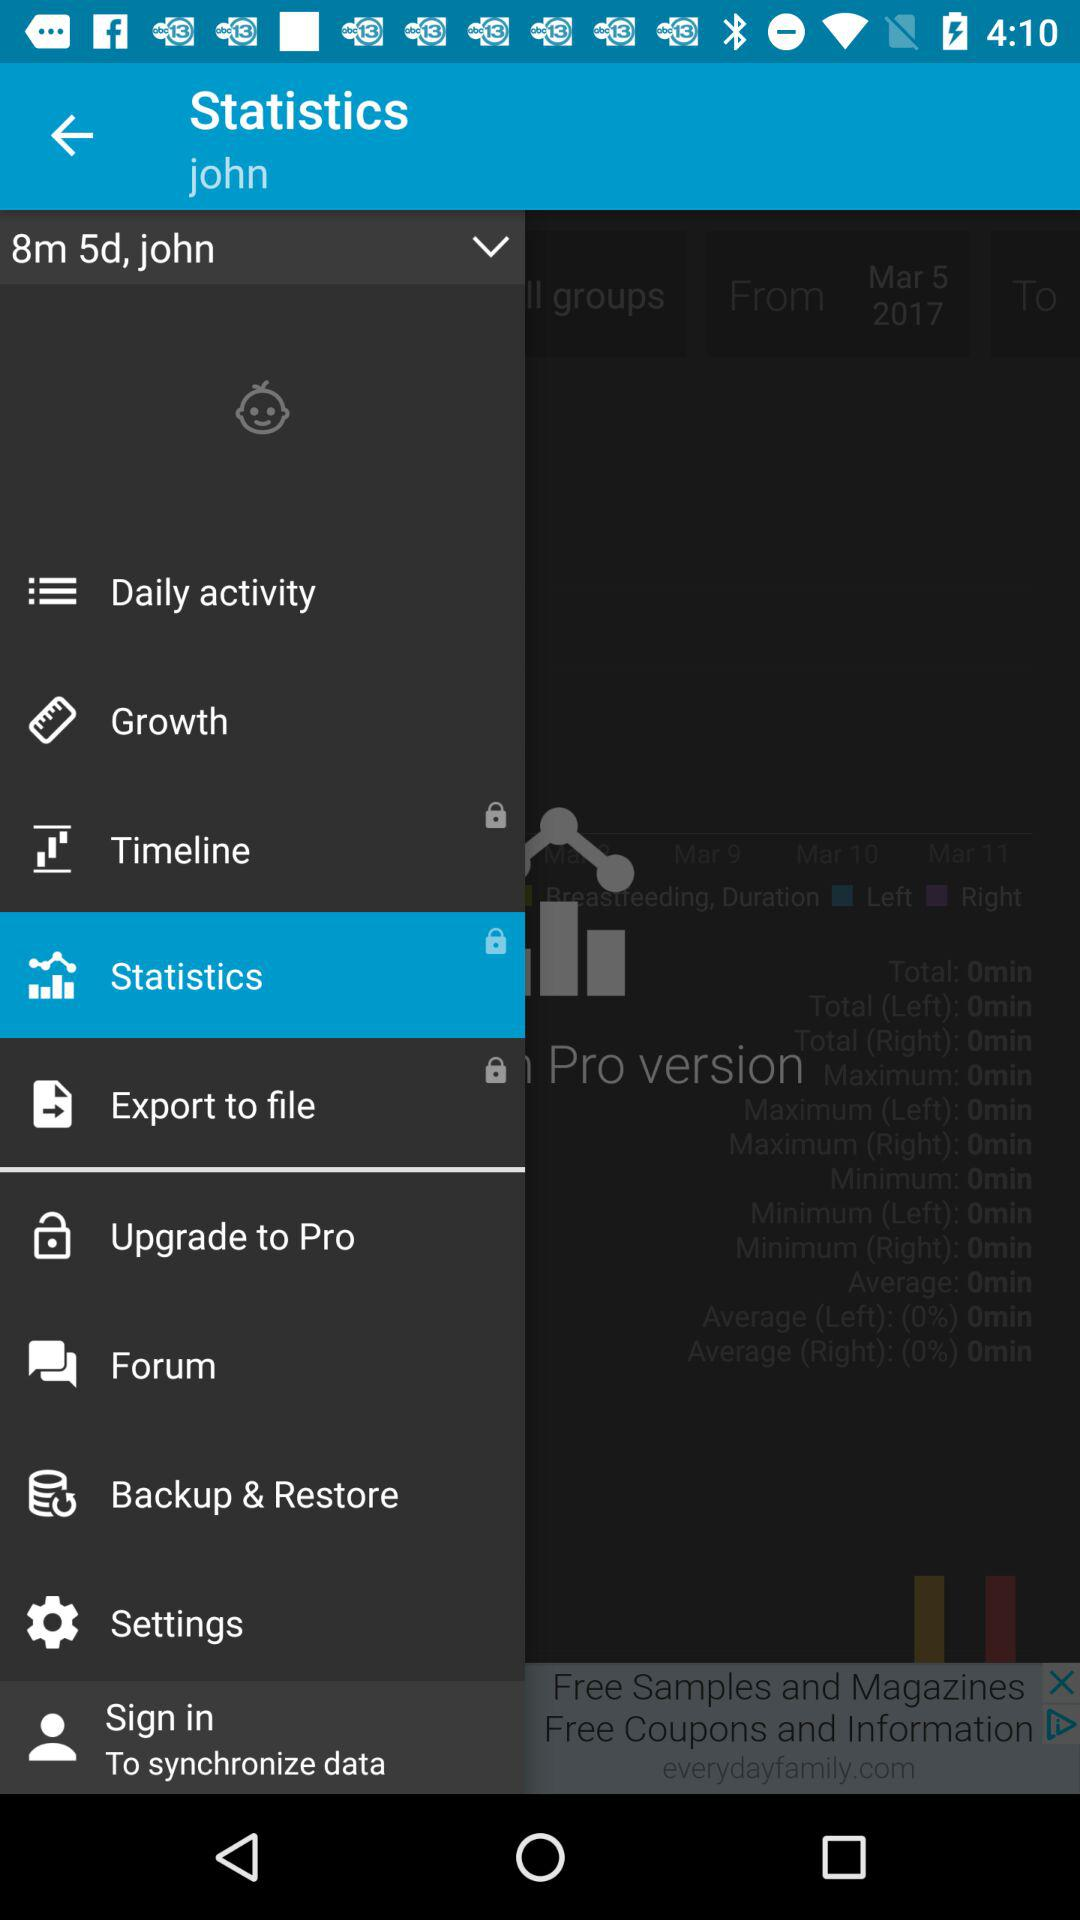How many items are locked?
Answer the question using a single word or phrase. 3 